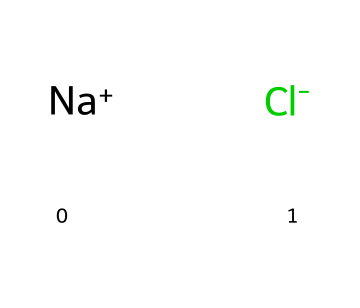what is the name of this compound? The SMILES representation indicates the presence of sodium (Na) and chloride (Cl) ions, which together form the compound sodium chloride, commonly known as table salt.
Answer: sodium chloride how many atoms are in the chemical structure? The structure consists of two ions: one sodium ion and one chloride ion. Thus, there are a total of two atoms in the chemical structure.
Answer: 2 what type of chemical bond is present in this compound? Sodium chloride is an ionic compound where sodium donates an electron to chloride, resulting in the formation of ionic bonds between the positively charged sodium ions and negatively charged chloride ions.
Answer: ionic what is the charge of the sodium ion? The sodium ion is represented by "[Na+]", indicating that it carries a positive charge of +1.
Answer: +1 what is the primary application of sodium chloride in Vancouver winters? Sodium chloride is primarily used for de-icing roads during winter to lower the freezing point of water, preventing the formation of ice.
Answer: road de-icing how does sodium chloride affect the freezing point of water? Sodium chloride lowers the freezing point of water through a colligative property, which means it disrupts the formation of ice crystals, allowing water to remain liquid at lower temperatures.
Answer: lowers the freezing point why is sodium chloride preferred over other de-icing agents? Sodium chloride is preferred due to its effectiveness, availability, and low cost compared to other de-icing materials, making it a common choice for municipalities.
Answer: effectiveness, availability, low cost 